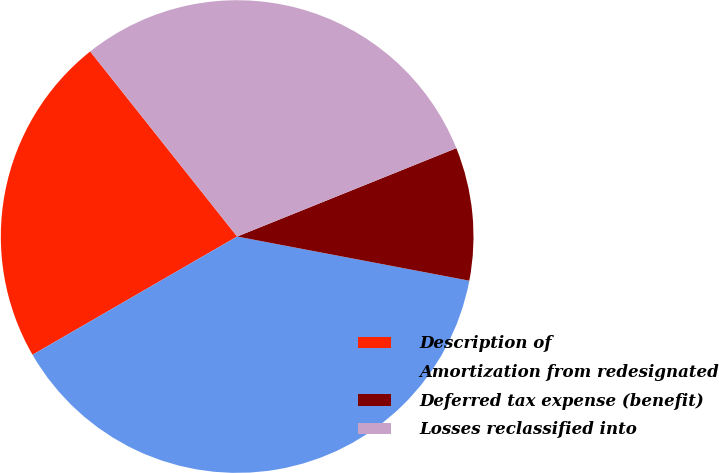Convert chart to OTSL. <chart><loc_0><loc_0><loc_500><loc_500><pie_chart><fcel>Description of<fcel>Amortization from redesignated<fcel>Deferred tax expense (benefit)<fcel>Losses reclassified into<nl><fcel>22.66%<fcel>38.67%<fcel>9.09%<fcel>29.58%<nl></chart> 